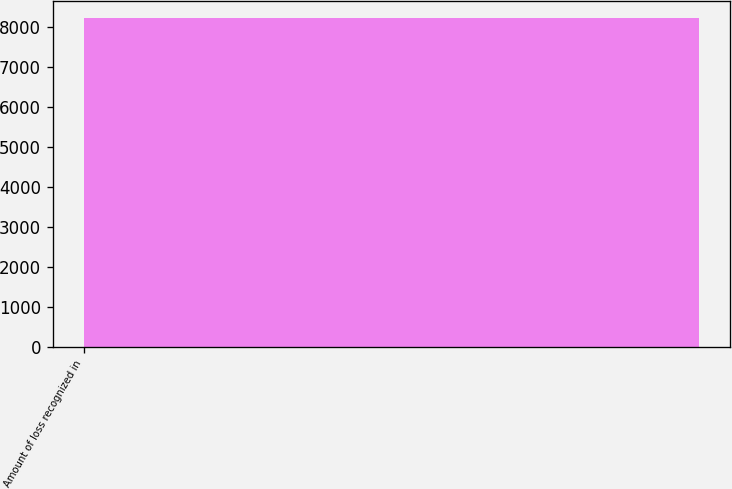Convert chart to OTSL. <chart><loc_0><loc_0><loc_500><loc_500><bar_chart><fcel>Amount of loss recognized in<nl><fcel>8240<nl></chart> 